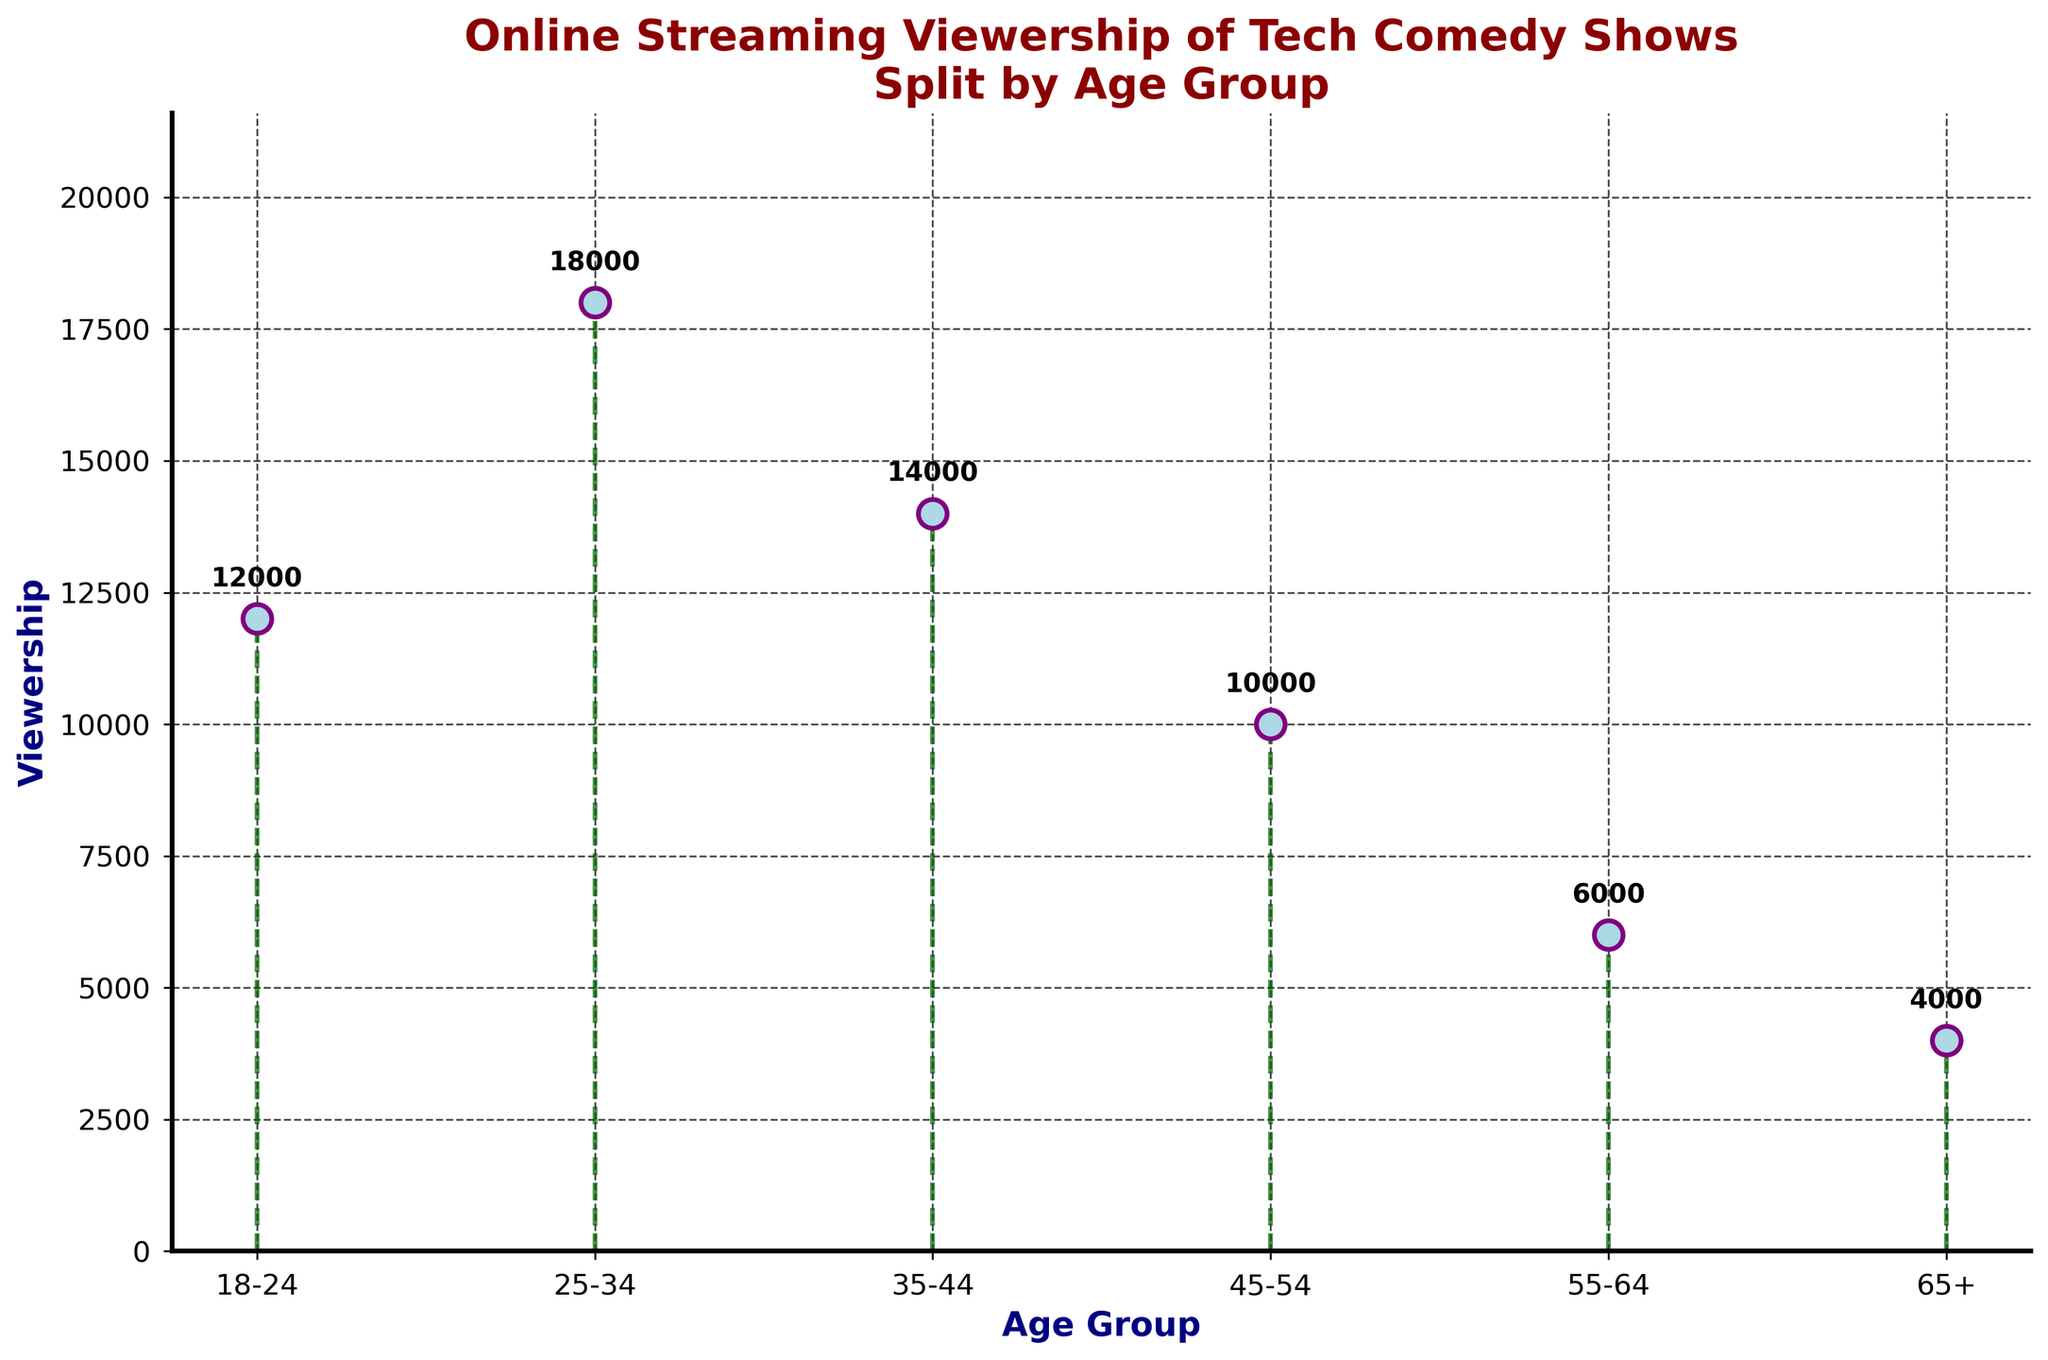What is the title of the plot? The title of the plot is displayed at the top of the figure. It reads: 'Online Streaming Viewership of Tech Comedy Shows Split by Age Group'
Answer: Online Streaming Viewership of Tech Comedy Shows Split by Age Group What's the highest viewership by age group and what is the value? The plot shows markers at different heights representing viewership numbers in thousands. The tallest marker corresponds to the age group 25-34 with 18,000 viewers.
Answer: 25-34, 18,000 How many age groups are represented in the plot? The x-axis shows various age groups from left to right. Counting these, we see there are six distinct age groups represented: 18-24, 25-34, 35-44, 45-54, 55-64, and 65+.
Answer: 6 Which age group has the lowest viewership and what is the value? The lowest marker on the plot indicates the smallest viewership, which corresponds to the age group 65+ with 4,000 viewers.
Answer: 65+, 4,000 What is the combined viewership of the age groups 18-24 and 45-54? Summing the viewership values for the age groups 18-24 (12,000) and 45-54 (10,000), we get 12,000 + 10,000 = 22,000.
Answer: 22,000 What is the difference in viewership between the age groups 35-44 and 55-64? To find the difference, subtract the viewership of age group 55-64 (6,000) from that of 35-44 (14,000): 14,000 - 6,000 = 8,000.
Answer: 8,000 Which two adjacent age groups have the smallest viewership difference and what is that difference? Checking the viewership differences between consecutive age groups: (25-34 to 18-24 is 6,000; 35-44 to 25-34 is 4,000; 45-54 to 35-44 is 4,000; 55-64 to 45-54 is 4,000; 65+ to 55-64 is 2,000). The smallest difference is 2,000 between 55-64 and 65+.
Answer: 55-64 and 65+, 2,000 What is the average viewership across all age groups? The total viewership is the sum of all viewership numbers: 12,000 + 18,000 + 14,000 + 10,000 + 6,000 + 4,000 = 64,000. Dividing by the number of age groups (6), we get 64,000 / 6 = approximately 10,667.
Answer: About 10,667 What can be said about the trend of viewership as age increases? The plot shows a decrease in viewership as the age groups increase, starting high at 25-34 and gradually falling to the lowest at 65+. This indicates a downward trend in viewership with increasing age.
Answer: Decreasing trend What does the baseline represent in the stem plot? In a stem plot, the baseline is a horizontal line that represents zero viewership. All stems start from this baseline, and it is colored red in the plot.
Answer: Zero viewership 